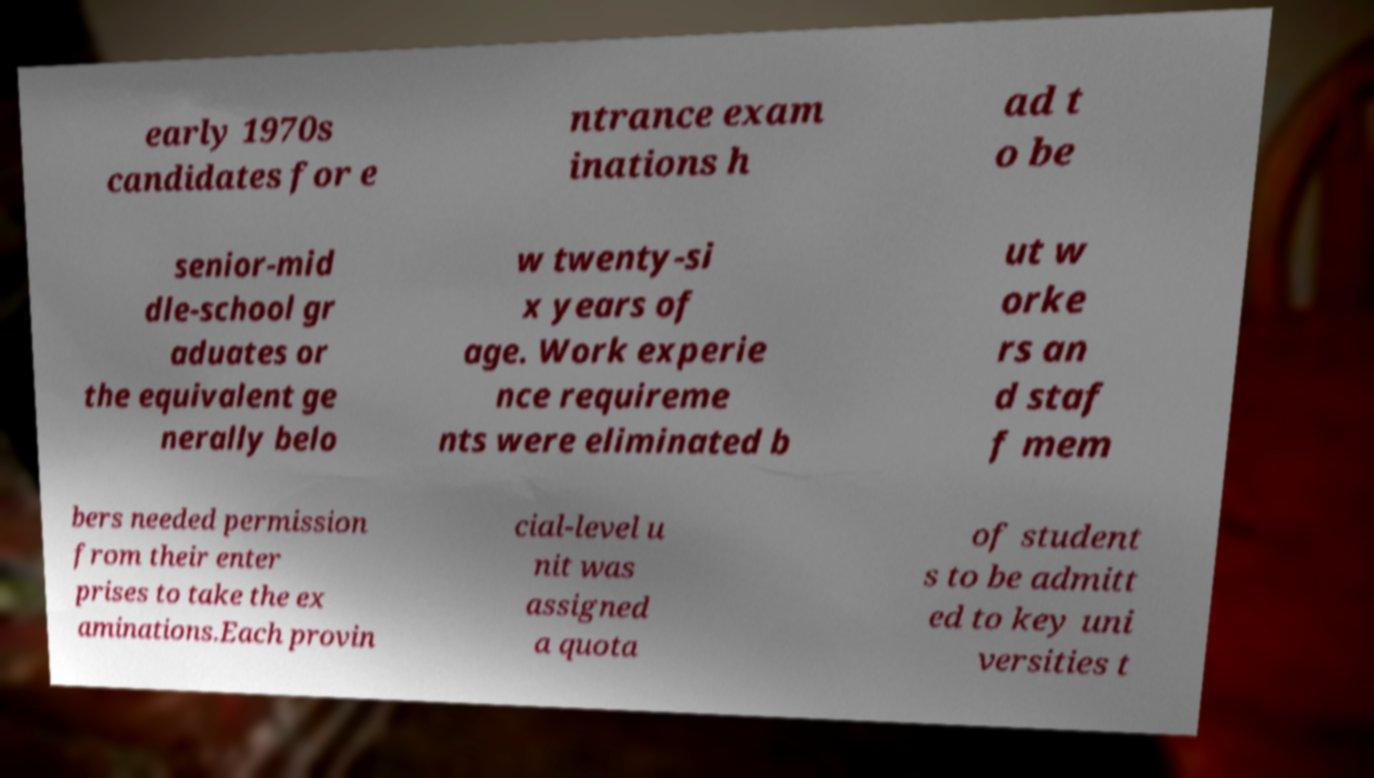Could you extract and type out the text from this image? early 1970s candidates for e ntrance exam inations h ad t o be senior-mid dle-school gr aduates or the equivalent ge nerally belo w twenty-si x years of age. Work experie nce requireme nts were eliminated b ut w orke rs an d staf f mem bers needed permission from their enter prises to take the ex aminations.Each provin cial-level u nit was assigned a quota of student s to be admitt ed to key uni versities t 